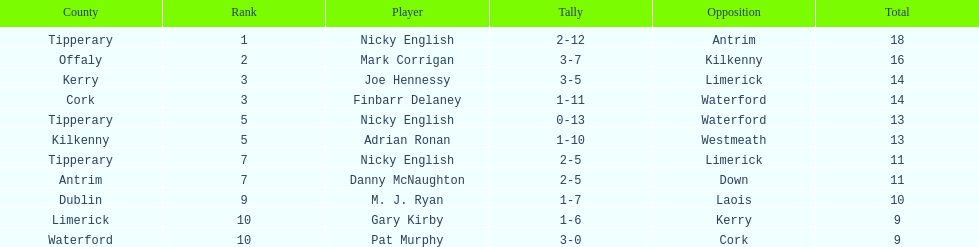Who ranked above mark corrigan? Nicky English. 